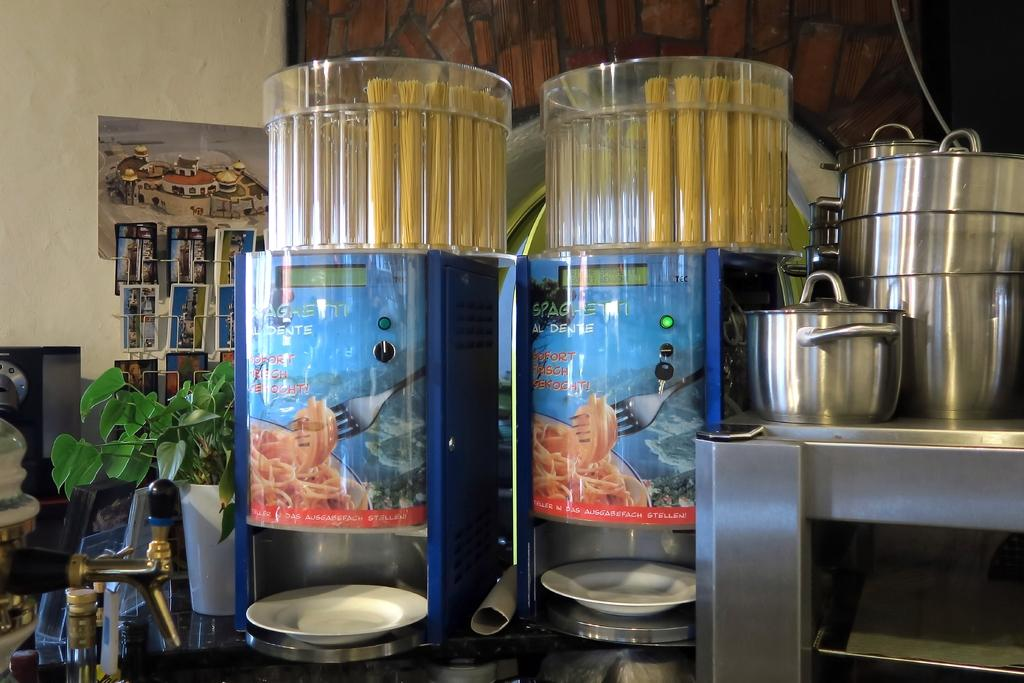<image>
Relay a brief, clear account of the picture shown. A pasta machine indicates that it can make spaghetti al dante. 